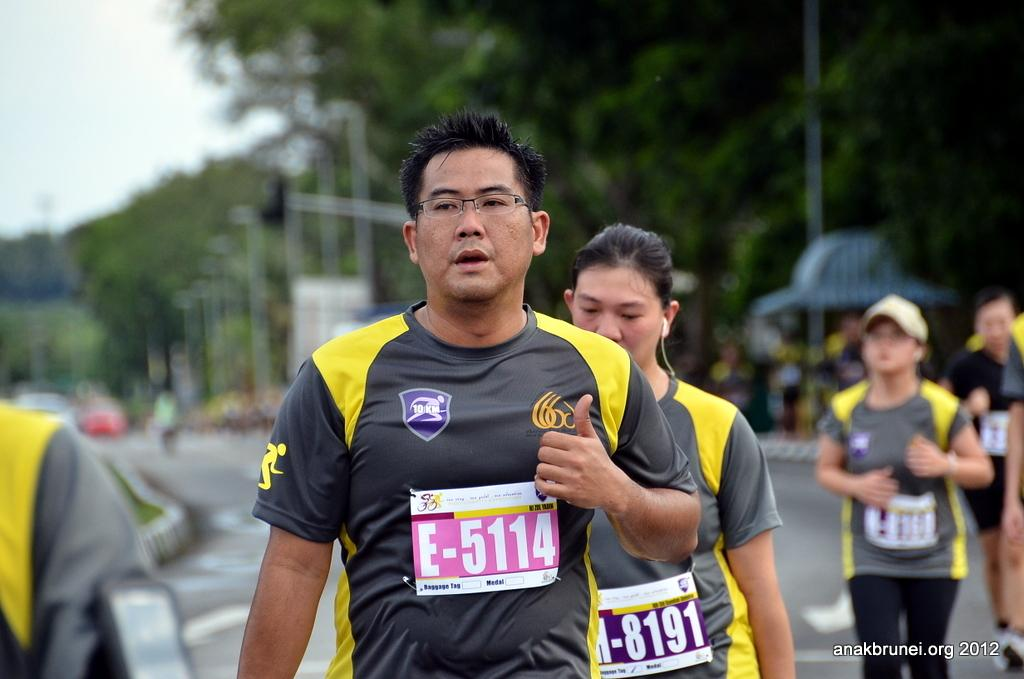What can be seen in the image regarding the people? There are persons wearing clothes in the image. Is there any text present in the image? Yes, there is a text in the bottom right corner of the image. How would you describe the background of the image? The background of the image is blurred. What type of breakfast is being served in the image? There is no breakfast present in the image; it only features persons wearing clothes and a blurred background. 